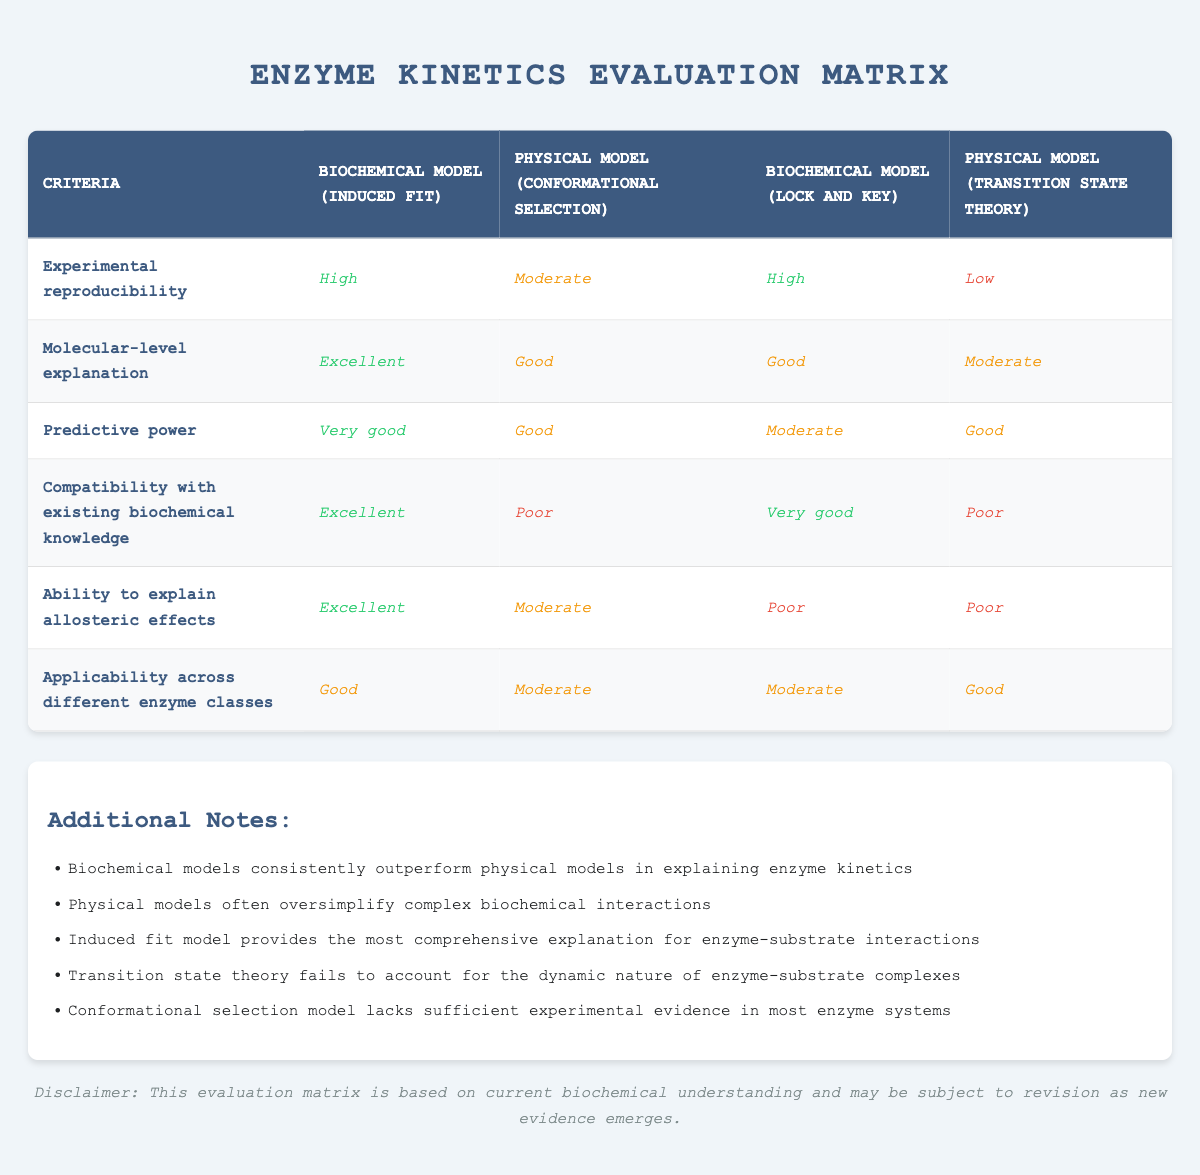What is the score for the biochemical model (induced fit) in terms of molecular-level explanation? Referring to the table, the score for the biochemical model (induced fit) under molecular-level explanation is marked as "Excellent."
Answer: Excellent Which model scores the lowest in experimental reproducibility? The table indicates that the physical model (transition state theory) received the lowest score of "Low" in the experimental reproducibility category.
Answer: Low What is the average score for the biochemical models across all criteria? The scores for the biochemical models (induced fit and lock and key) can be quantified as follows: Induced fit: High, Excellent, Very good, Excellent, Excellent, Good (converting qualitative scores to numerical values: High=3, Excellent=4, Very good=3.5, Good=3, Moderate=2, Poor=1): (3 + 4 + 3.5 + 4 + 4 + 3) / 6 = 3.58. So, calculating similarly for Lock and Key: (3 + 2 + 2 + 3.5 + 1 + 2) / 6 = 2.25. Thus, the average is (3.58 + 2.25) / 2 = 2.915.
Answer: 2.915 Does the physical model (conformational selection) provide an excellent score in compatibility with existing biochemical knowledge? The table shows that the physical model (conformational selection) received a score of "Poor" in compatibility with existing biochemical knowledge, therefore it does not provide an excellent score.
Answer: No Of the four explanations, which model has the highest overall predictive power? By reviewing the scores, the biochemical model (induced fit) has a score of "Very good" while the other models score lower. Thus, the induced fit model has the highest overall predictive power.
Answer: Biochemical model (induced fit) 